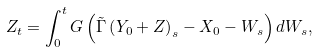<formula> <loc_0><loc_0><loc_500><loc_500>Z _ { t } = \int _ { 0 } ^ { t } G \left ( \tilde { \Gamma } \left ( Y _ { 0 } + Z \right ) _ { s } - X _ { 0 } - W _ { s } \right ) d W _ { s } ,</formula> 